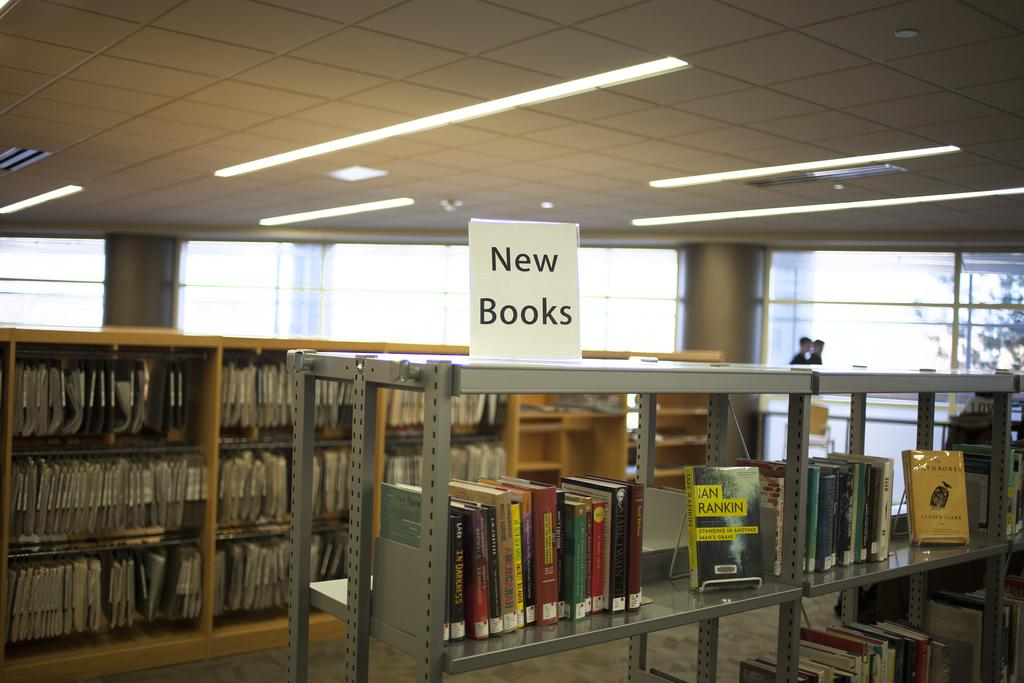<image>
Describe the image concisely. Book store with a sign that says New Books on top. 